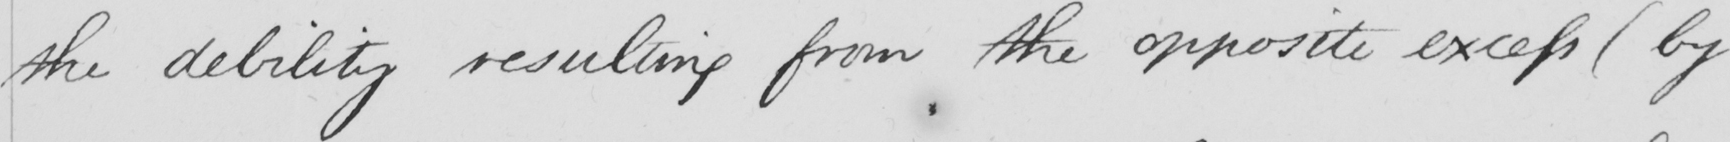What text is written in this handwritten line? the debility resulting from the opposite excess  ( by 